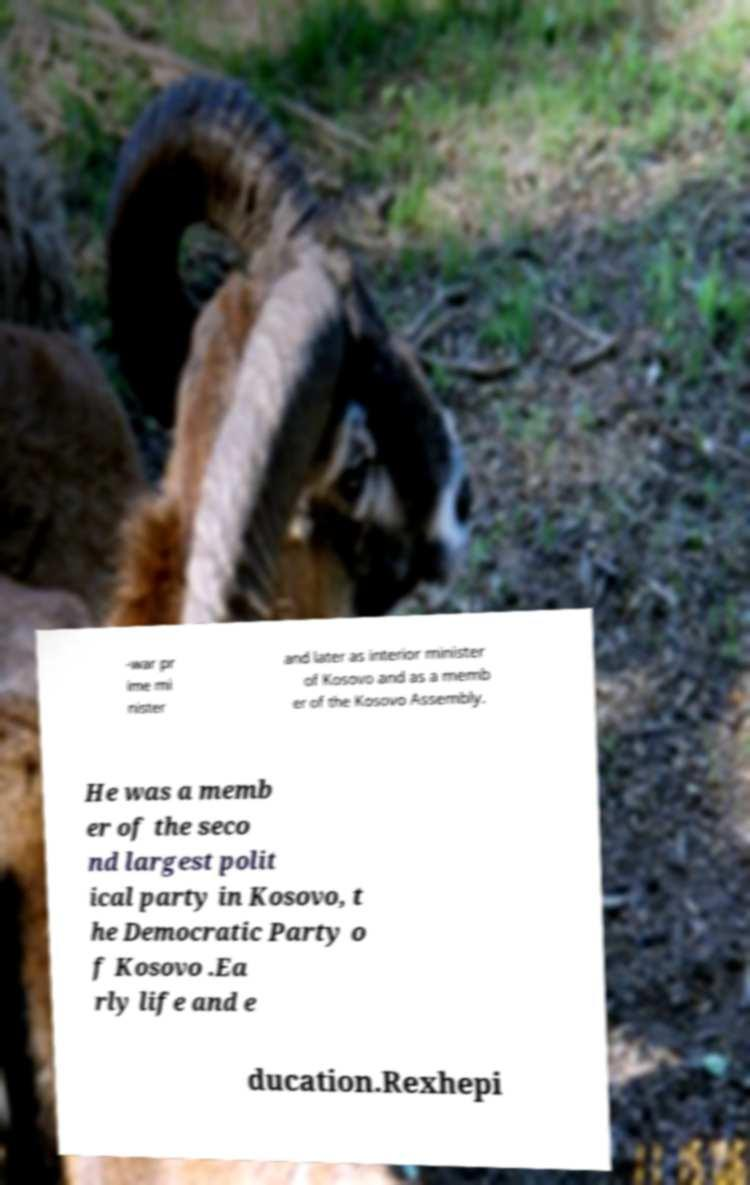There's text embedded in this image that I need extracted. Can you transcribe it verbatim? -war pr ime mi nister and later as interior minister of Kosovo and as a memb er of the Kosovo Assembly. He was a memb er of the seco nd largest polit ical party in Kosovo, t he Democratic Party o f Kosovo .Ea rly life and e ducation.Rexhepi 